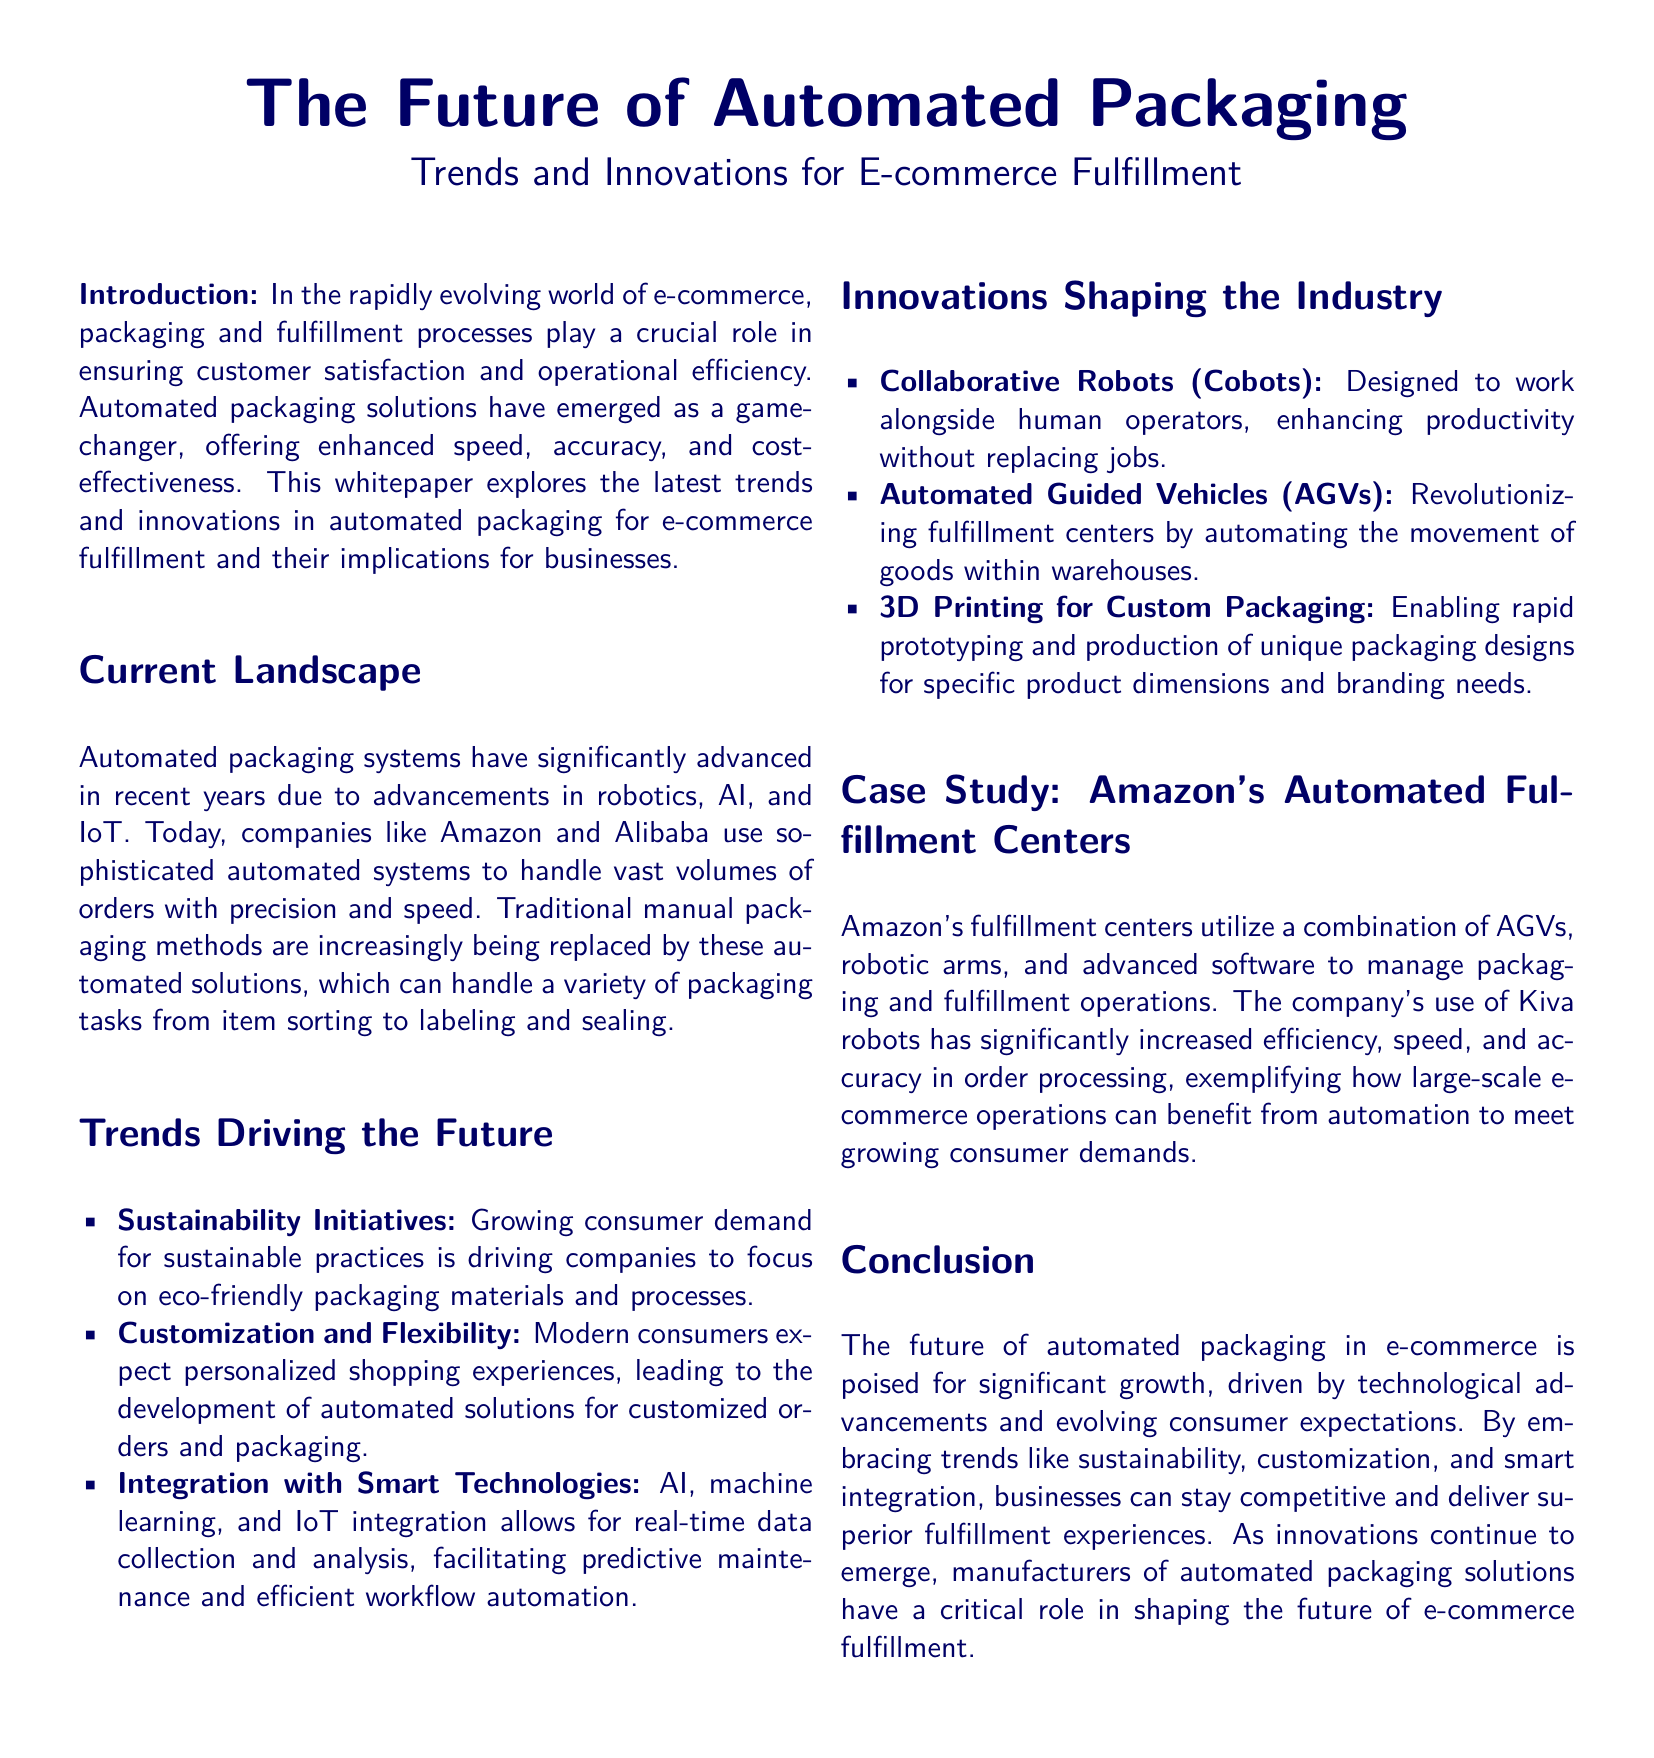What are the current trends driving automated packaging? The document lists several trends driving automated packaging, including sustainability initiatives, customization and flexibility, and integration with smart technologies.
Answer: Sustainability initiatives, customization and flexibility, integration with smart technologies Who are the major companies mentioned using automated systems? The document mentions companies like Amazon and Alibaba as major players utilizing sophisticated automated systems in their packaging and fulfillment processes.
Answer: Amazon and Alibaba What innovative technology is used for custom packaging? The document highlights 3D printing as an innovative technology enabling custom packaging creation for specific products.
Answer: 3D printing What type of robots are designed to work alongside human operators? The document refers to collaborative robots, or cobots, which are designed to enhance productivity by working with human operators.
Answer: Cobots What impact has Amazon's use of Kiva robots had on its operations? The document states that Amazon's use of Kiva robots has significantly increased efficiency, speed, and accuracy in order processing.
Answer: Increased efficiency, speed, and accuracy What is the main focus of sustainability initiatives in automated packaging? The document indicates that sustainability initiatives are focused on eco-friendly packaging materials and processes in response to consumer demand.
Answer: Eco-friendly packaging materials and processes How do Automated Guided Vehicles (AGVs) influence fulfillment centers? The document explains that AGVs are revolutionizing fulfillment centers by automating the movement of goods within warehouses.
Answer: Automating the movement of goods What is the primary function of automated packaging solutions in e-commerce? According to the document, the primary function of automated packaging solutions is to enhance speed, accuracy, and cost-effectiveness in e-commerce fulfillment.
Answer: Enhance speed, accuracy, and cost-effectiveness 